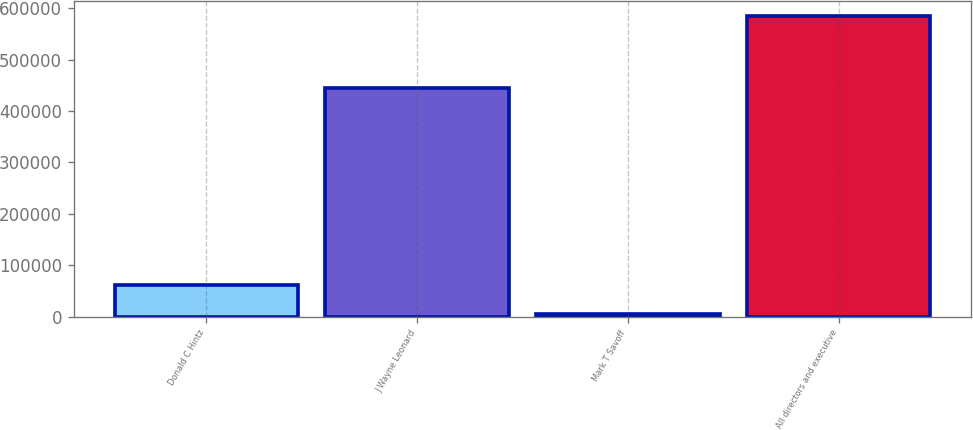<chart> <loc_0><loc_0><loc_500><loc_500><bar_chart><fcel>Donald C Hintz<fcel>J Wayne Leonard<fcel>Mark T Savoff<fcel>All directors and executive<nl><fcel>62443.7<fcel>444898<fcel>4363<fcel>585170<nl></chart> 